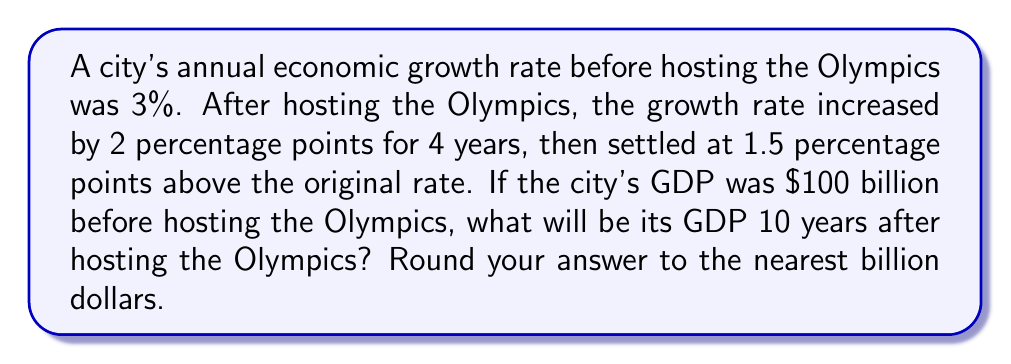Provide a solution to this math problem. Let's approach this step-by-step:

1) Initial GDP: $100 billion

2) Growth rates:
   - Before Olympics: 3%
   - First 4 years after Olympics: 3% + 2% = 5%
   - Remaining 6 years: 3% + 1.5% = 4.5%

3) Let's calculate the GDP growth for each period:

   For the first 4 years (5% growth):
   $$100 \times (1.05)^4 = 100 \times 1.2155 = 121.55$$

   For the next 6 years (4.5% growth):
   $$121.55 \times (1.045)^6 = 121.55 \times 1.3026 = 158.33$$

4) Therefore, after 10 years, the GDP would be approximately $158.33 billion.

5) Rounding to the nearest billion: $158 billion.
Answer: $158 billion 